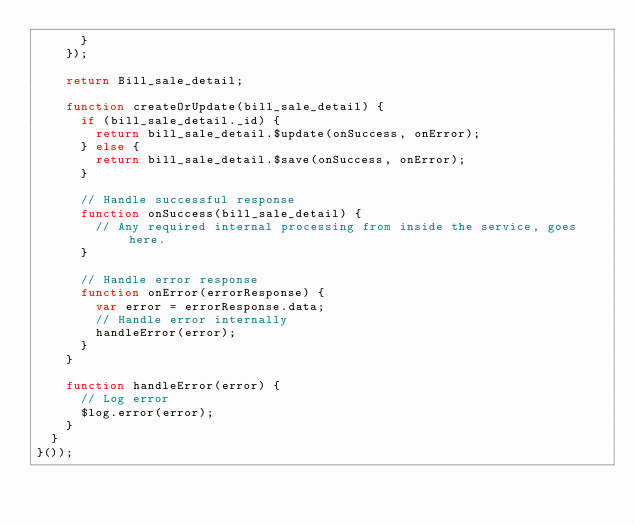<code> <loc_0><loc_0><loc_500><loc_500><_JavaScript_>      }
    });

    return Bill_sale_detail;

    function createOrUpdate(bill_sale_detail) {
      if (bill_sale_detail._id) {
        return bill_sale_detail.$update(onSuccess, onError);
      } else {
        return bill_sale_detail.$save(onSuccess, onError);
      }

      // Handle successful response
      function onSuccess(bill_sale_detail) {
        // Any required internal processing from inside the service, goes here.
      }

      // Handle error response
      function onError(errorResponse) {
        var error = errorResponse.data;
        // Handle error internally
        handleError(error);
      }
    }

    function handleError(error) {
      // Log error
      $log.error(error);
    }
  }
}());
</code> 